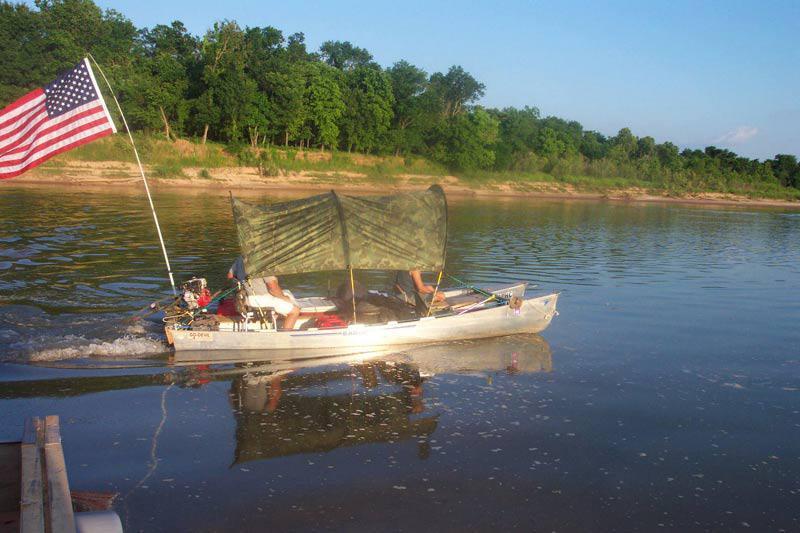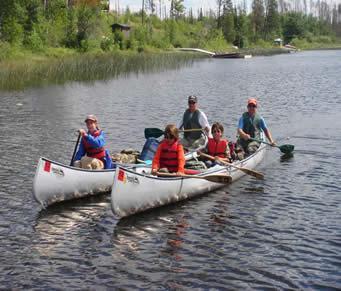The first image is the image on the left, the second image is the image on the right. Examine the images to the left and right. Is the description "Both images show multiple people inside a double-rigger canoe that is at least partially on the water." accurate? Answer yes or no. Yes. The first image is the image on the left, the second image is the image on the right. Examine the images to the left and right. Is the description "There is an American flag on the boat in the image on the left." accurate? Answer yes or no. Yes. 